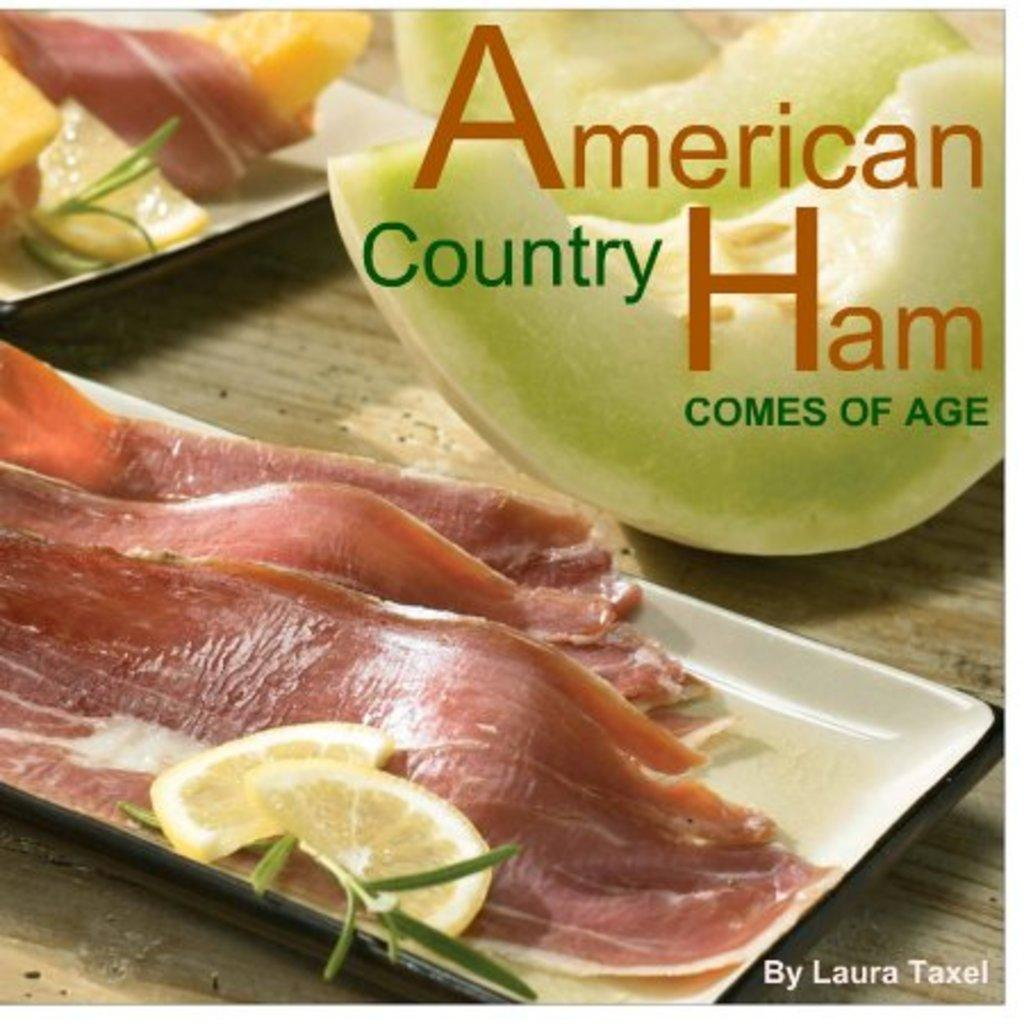What type of food can be seen in the image? There are meat slices and cucumber pieces in the image. What other fruit or vegetable is present in the image? There is a lime in the image. How are the meat slices and lime arranged in the image? The meat slices and lime are in a tray. What else is on the tray besides the meat slices and lime? There are no other items on the tray besides the meat slices and lime. What is on the other plate in the image? The plate contains meat and salad. What type of table is visible in the image? The wooden table is visible in the image. Can you tell me how the monkey is requesting more food in the image? There is no monkey present in the image, and therefore no request for more food can be observed. What type of story is being told by the food in the image? The food in the image is not telling a story; it is simply arranged on plates and a tray. 